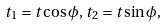Convert formula to latex. <formula><loc_0><loc_0><loc_500><loc_500>t _ { 1 } = t \cos \phi , \, t _ { 2 } = t \sin \phi ,</formula> 